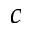<formula> <loc_0><loc_0><loc_500><loc_500>c</formula> 